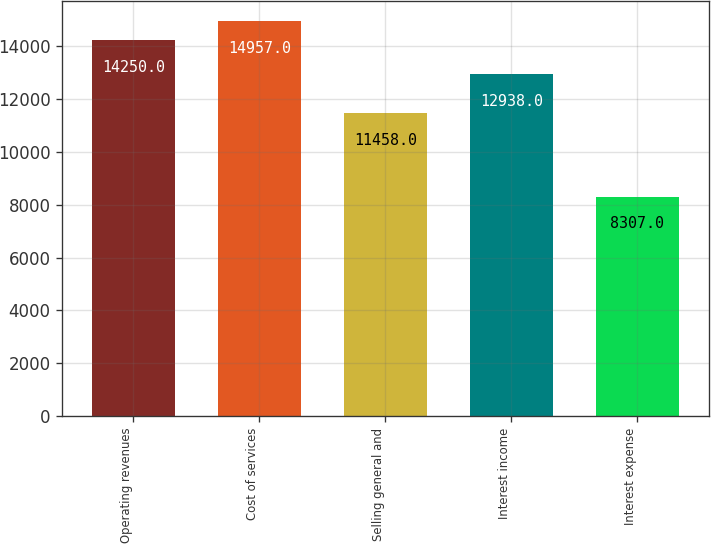<chart> <loc_0><loc_0><loc_500><loc_500><bar_chart><fcel>Operating revenues<fcel>Cost of services<fcel>Selling general and<fcel>Interest income<fcel>Interest expense<nl><fcel>14250<fcel>14957<fcel>11458<fcel>12938<fcel>8307<nl></chart> 